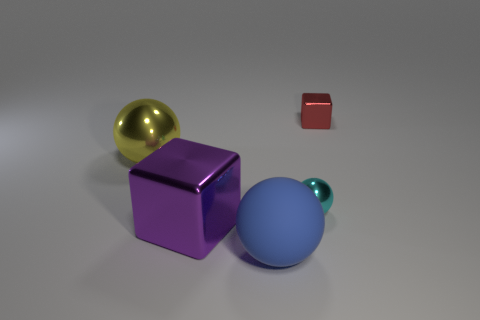Subtract all brown balls. Subtract all yellow blocks. How many balls are left? 3 Add 2 tiny green metal balls. How many objects exist? 7 Subtract all blocks. How many objects are left? 3 Add 3 yellow objects. How many yellow objects are left? 4 Add 4 small blocks. How many small blocks exist? 5 Subtract 0 green blocks. How many objects are left? 5 Subtract all large things. Subtract all rubber things. How many objects are left? 1 